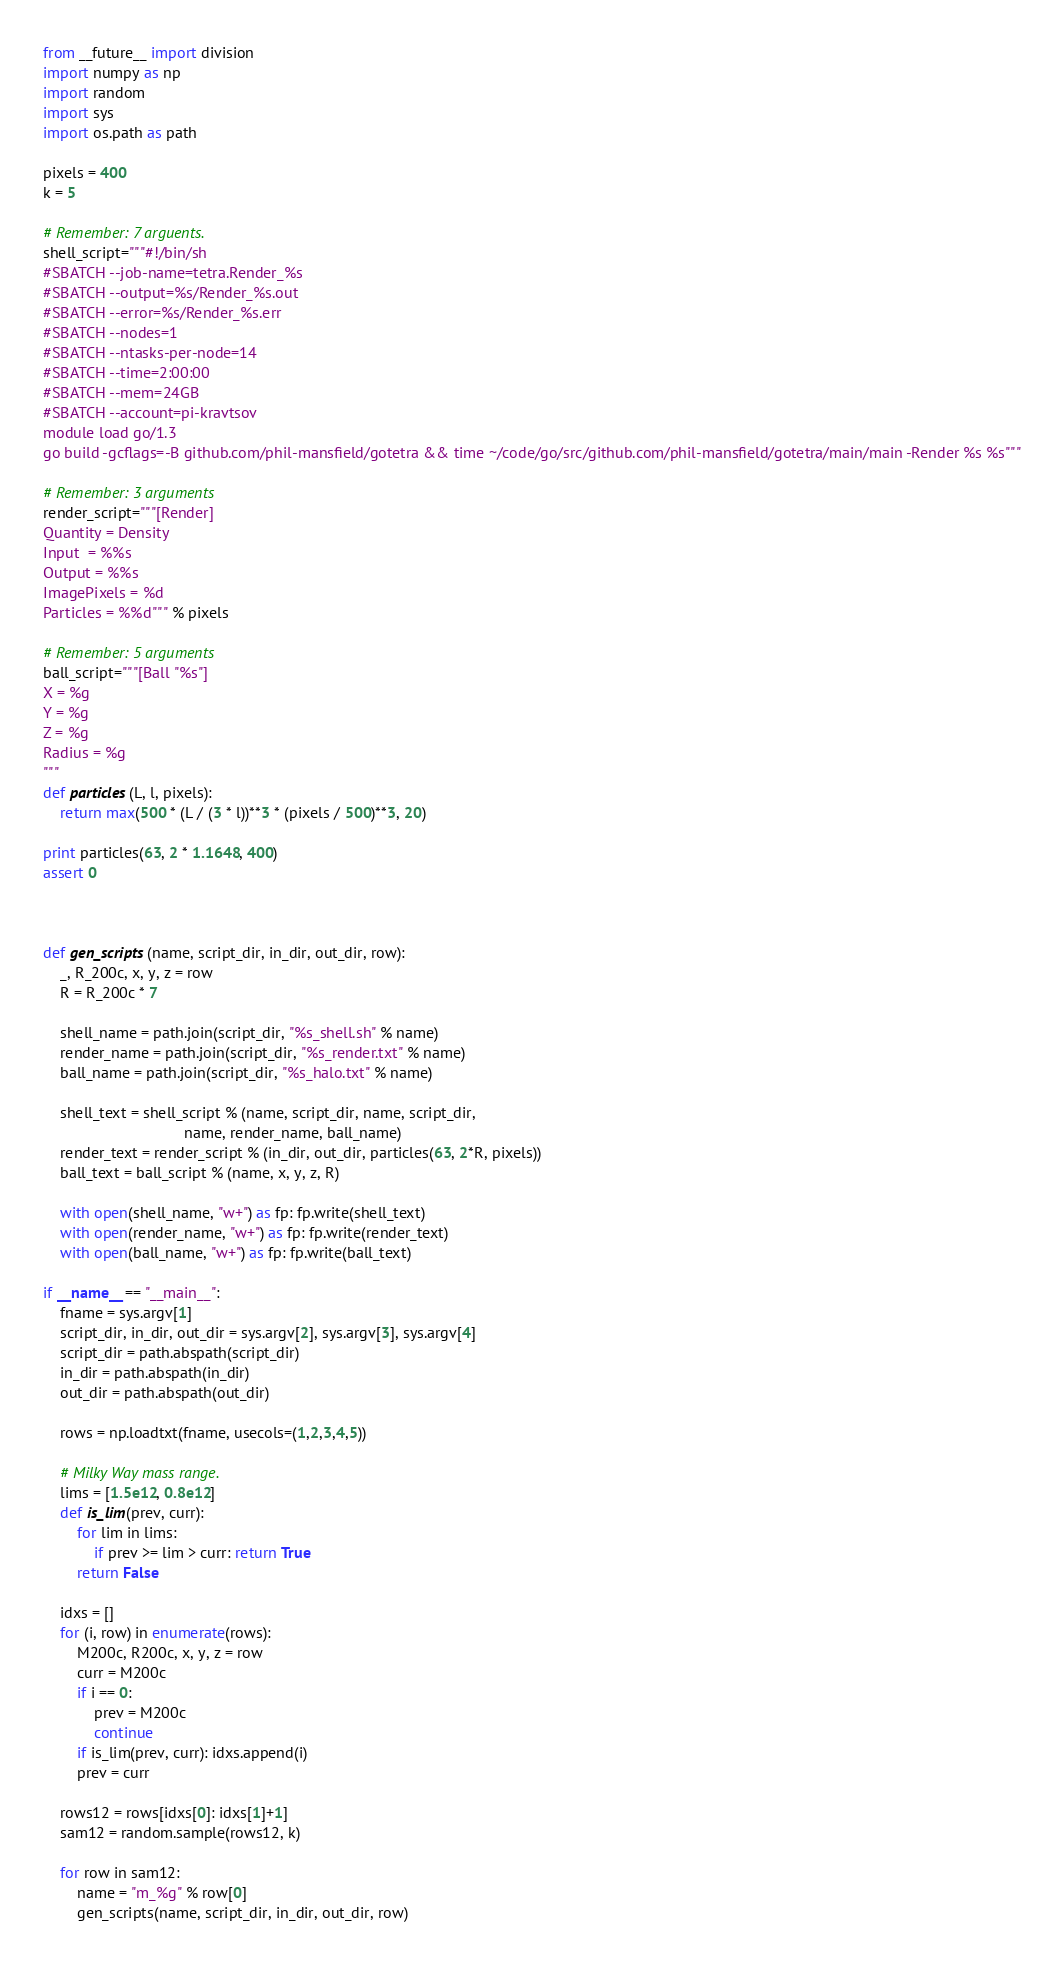<code> <loc_0><loc_0><loc_500><loc_500><_Python_>from __future__ import division
import numpy as np
import random
import sys
import os.path as path

pixels = 400
k = 5

# Remember: 7 arguents.
shell_script="""#!/bin/sh
#SBATCH --job-name=tetra.Render_%s
#SBATCH --output=%s/Render_%s.out
#SBATCH --error=%s/Render_%s.err
#SBATCH --nodes=1
#SBATCH --ntasks-per-node=14
#SBATCH --time=2:00:00
#SBATCH --mem=24GB
#SBATCH --account=pi-kravtsov
module load go/1.3
go build -gcflags=-B github.com/phil-mansfield/gotetra && time ~/code/go/src/github.com/phil-mansfield/gotetra/main/main -Render %s %s"""

# Remember: 3 arguments
render_script="""[Render]
Quantity = Density
Input  = %%s
Output = %%s
ImagePixels = %d
Particles = %%d""" % pixels

# Remember: 5 arguments
ball_script="""[Ball "%s"]
X = %g
Y = %g
Z = %g
Radius = %g
"""
def particles(L, l, pixels):
    return max(500 * (L / (3 * l))**3 * (pixels / 500)**3, 20)

print particles(63, 2 * 1.1648, 400)
assert 0



def gen_scripts(name, script_dir, in_dir, out_dir, row):
    _, R_200c, x, y, z = row
    R = R_200c * 7

    shell_name = path.join(script_dir, "%s_shell.sh" % name)
    render_name = path.join(script_dir, "%s_render.txt" % name)
    ball_name = path.join(script_dir, "%s_halo.txt" % name)
    
    shell_text = shell_script % (name, script_dir, name, script_dir,
                                 name, render_name, ball_name)
    render_text = render_script % (in_dir, out_dir, particles(63, 2*R, pixels))
    ball_text = ball_script % (name, x, y, z, R)

    with open(shell_name, "w+") as fp: fp.write(shell_text)
    with open(render_name, "w+") as fp: fp.write(render_text)
    with open(ball_name, "w+") as fp: fp.write(ball_text)

if __name__ == "__main__":
    fname = sys.argv[1]
    script_dir, in_dir, out_dir = sys.argv[2], sys.argv[3], sys.argv[4]
    script_dir = path.abspath(script_dir)
    in_dir = path.abspath(in_dir)
    out_dir = path.abspath(out_dir)

    rows = np.loadtxt(fname, usecols=(1,2,3,4,5))

    # Milky Way mass range.
    lims = [1.5e12, 0.8e12]
    def is_lim(prev, curr):
        for lim in lims:
            if prev >= lim > curr: return True
        return False

    idxs = []
    for (i, row) in enumerate(rows):
        M200c, R200c, x, y, z = row
        curr = M200c
        if i == 0:
            prev = M200c
            continue
        if is_lim(prev, curr): idxs.append(i)
        prev = curr

    rows12 = rows[idxs[0]: idxs[1]+1]
    sam12 = random.sample(rows12, k)

    for row in sam12:
        name = "m_%g" % row[0]
        gen_scripts(name, script_dir, in_dir, out_dir, row)
</code> 